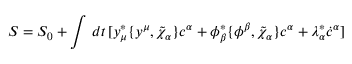<formula> <loc_0><loc_0><loc_500><loc_500>S = S _ { 0 } + \int \, d t \, [ y _ { \mu } ^ { * } \{ y ^ { \mu } , \tilde { \chi } _ { \alpha } \} c ^ { \alpha } + \phi _ { \beta } ^ { * } \{ \phi ^ { \beta } , \tilde { \chi } _ { \alpha } \} c ^ { \alpha } + \lambda _ { \alpha } ^ { * } \dot { c } ^ { \alpha } ]</formula> 